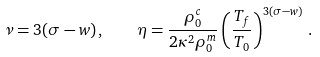Convert formula to latex. <formula><loc_0><loc_0><loc_500><loc_500>\nu = 3 ( \sigma - w ) \, , \quad \eta = \frac { \rho ^ { c } _ { 0 } } { 2 \kappa ^ { 2 } \rho ^ { m } _ { 0 } } \left ( \frac { T _ { f } } { T _ { 0 } } \right ) ^ { 3 ( \sigma - w ) } \, .</formula> 